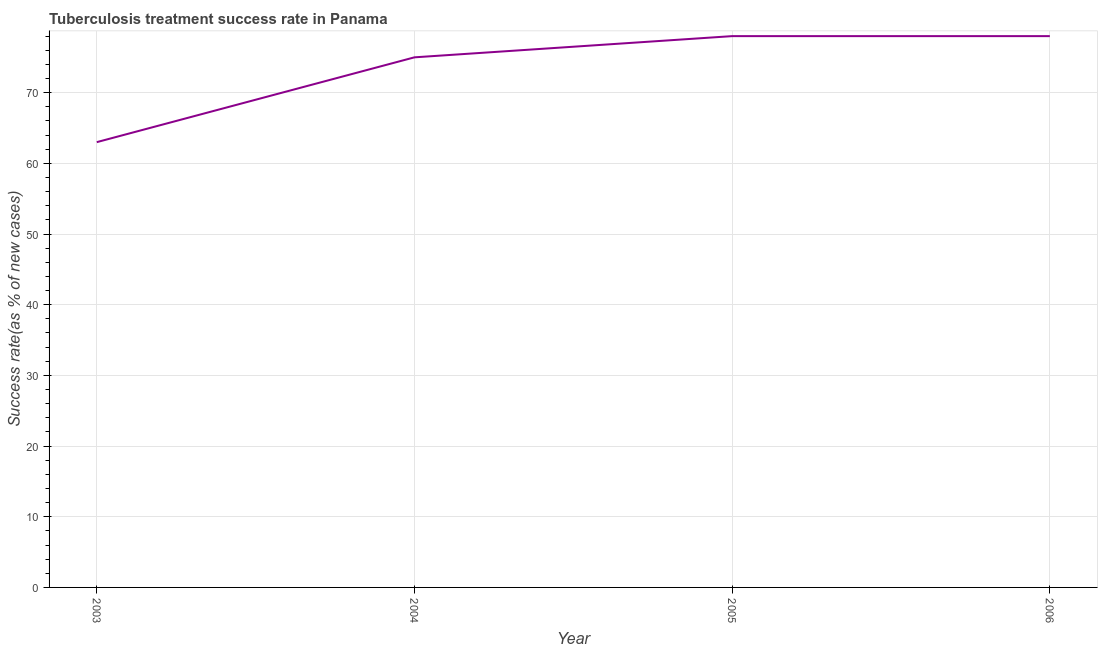What is the tuberculosis treatment success rate in 2006?
Keep it short and to the point. 78. Across all years, what is the maximum tuberculosis treatment success rate?
Provide a short and direct response. 78. Across all years, what is the minimum tuberculosis treatment success rate?
Keep it short and to the point. 63. In which year was the tuberculosis treatment success rate maximum?
Offer a very short reply. 2005. In which year was the tuberculosis treatment success rate minimum?
Your answer should be very brief. 2003. What is the sum of the tuberculosis treatment success rate?
Your answer should be very brief. 294. What is the difference between the tuberculosis treatment success rate in 2004 and 2006?
Keep it short and to the point. -3. What is the average tuberculosis treatment success rate per year?
Your answer should be very brief. 73.5. What is the median tuberculosis treatment success rate?
Offer a very short reply. 76.5. What is the ratio of the tuberculosis treatment success rate in 2005 to that in 2006?
Make the answer very short. 1. Is the tuberculosis treatment success rate in 2003 less than that in 2004?
Keep it short and to the point. Yes. What is the difference between the highest and the second highest tuberculosis treatment success rate?
Give a very brief answer. 0. What is the difference between the highest and the lowest tuberculosis treatment success rate?
Offer a very short reply. 15. In how many years, is the tuberculosis treatment success rate greater than the average tuberculosis treatment success rate taken over all years?
Offer a very short reply. 3. How many years are there in the graph?
Offer a very short reply. 4. Are the values on the major ticks of Y-axis written in scientific E-notation?
Your response must be concise. No. What is the title of the graph?
Give a very brief answer. Tuberculosis treatment success rate in Panama. What is the label or title of the Y-axis?
Keep it short and to the point. Success rate(as % of new cases). What is the Success rate(as % of new cases) in 2005?
Keep it short and to the point. 78. What is the Success rate(as % of new cases) in 2006?
Your answer should be compact. 78. What is the difference between the Success rate(as % of new cases) in 2003 and 2004?
Your answer should be compact. -12. What is the difference between the Success rate(as % of new cases) in 2003 and 2005?
Make the answer very short. -15. What is the difference between the Success rate(as % of new cases) in 2005 and 2006?
Offer a terse response. 0. What is the ratio of the Success rate(as % of new cases) in 2003 to that in 2004?
Provide a succinct answer. 0.84. What is the ratio of the Success rate(as % of new cases) in 2003 to that in 2005?
Your answer should be very brief. 0.81. What is the ratio of the Success rate(as % of new cases) in 2003 to that in 2006?
Your response must be concise. 0.81. What is the ratio of the Success rate(as % of new cases) in 2004 to that in 2005?
Ensure brevity in your answer.  0.96. 